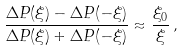<formula> <loc_0><loc_0><loc_500><loc_500>\frac { \Delta P ( \xi ) - \Delta P ( - \xi ) } { \Delta P ( \xi ) + \Delta P ( - \xi ) } \approx \frac { \xi _ { 0 } } { \xi } \, ,</formula> 